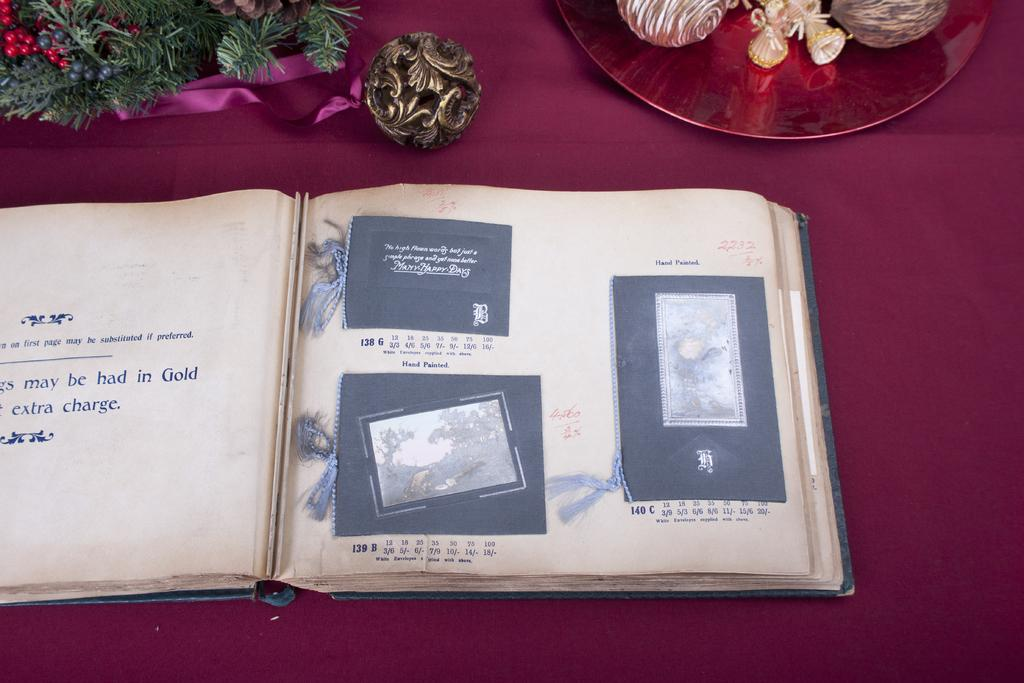<image>
Summarize the visual content of the image. An open book with the words extra charge on the left side. 